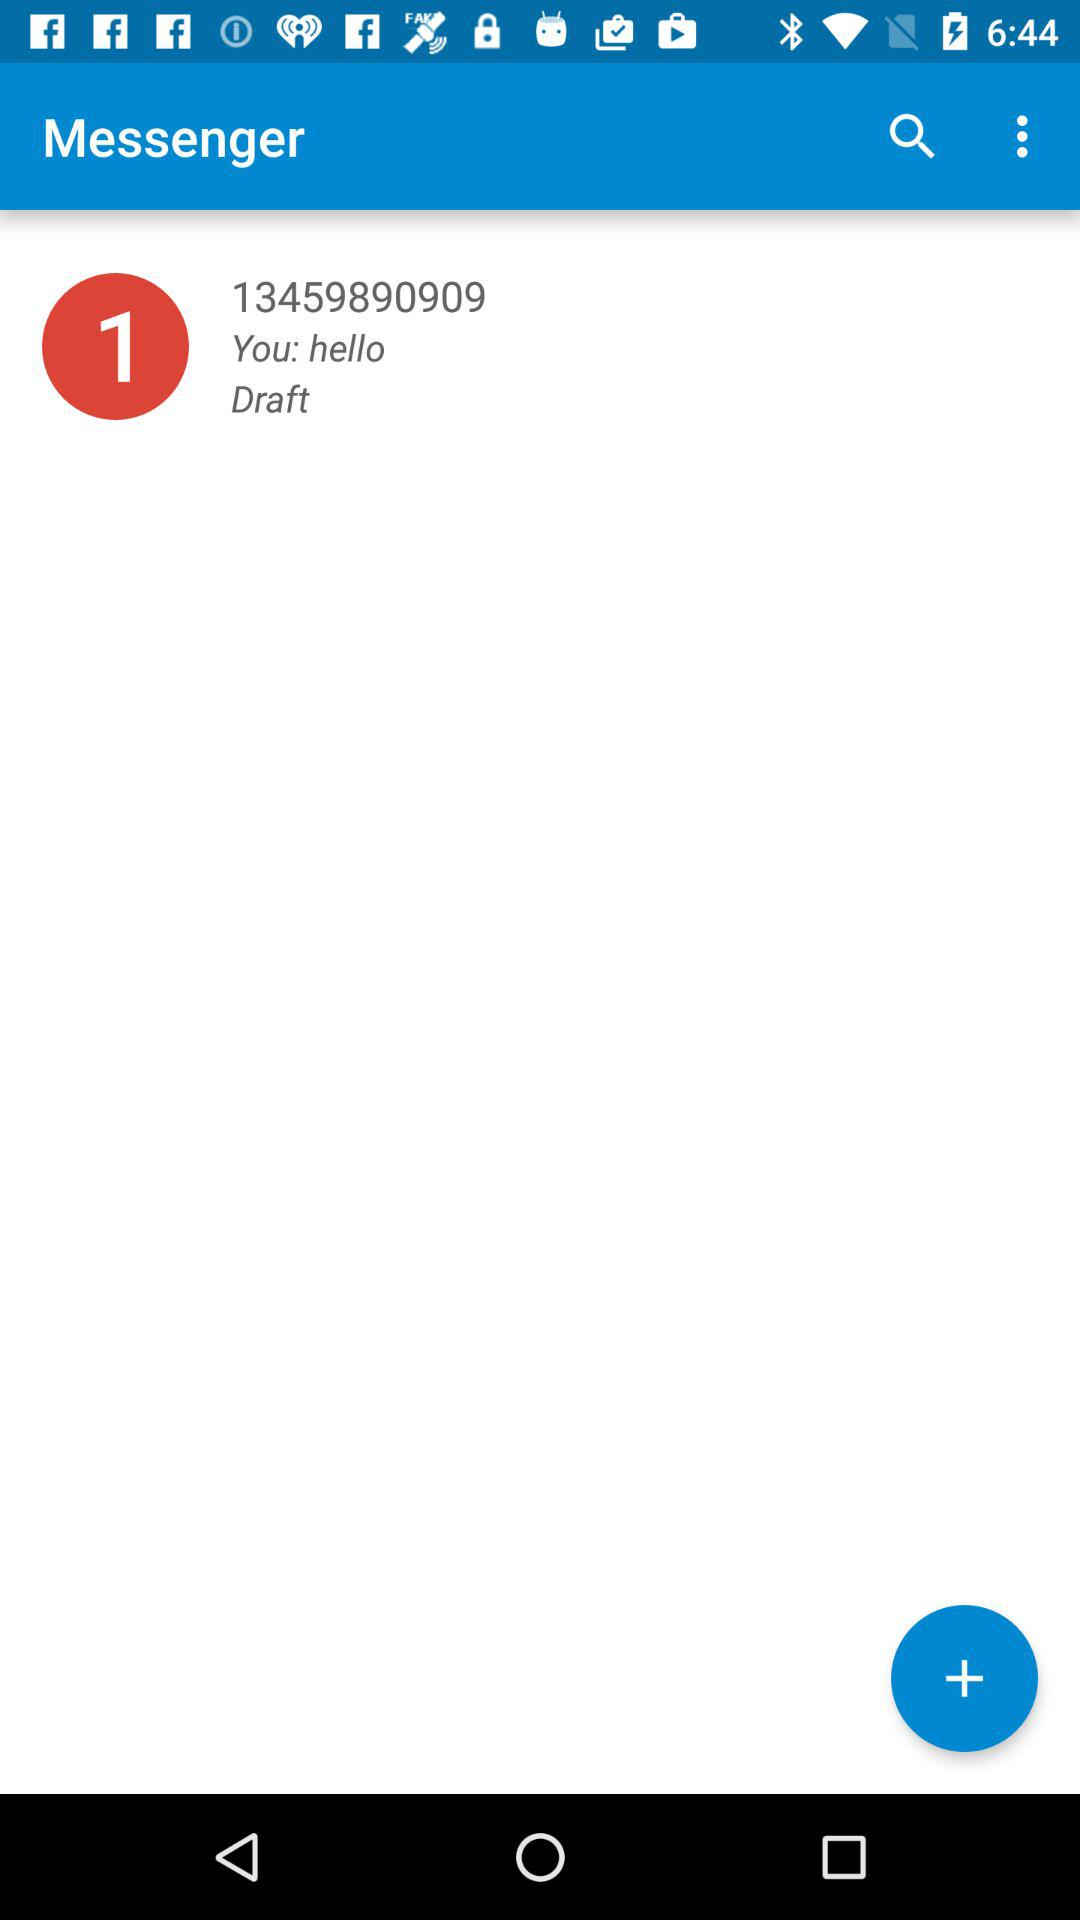What's the mobile number? The mobile number is 13459890909. 